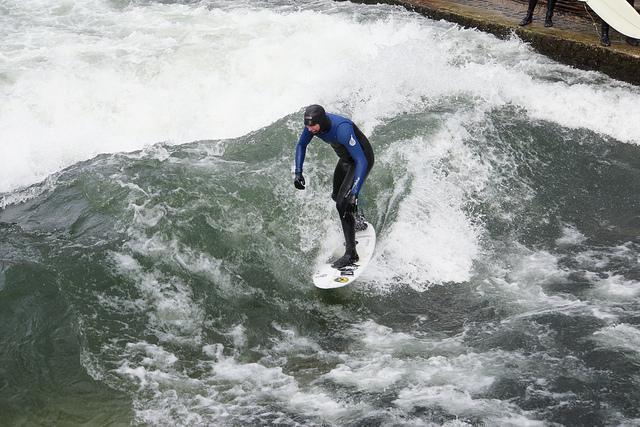How many cats are on the sink?
Give a very brief answer. 0. 